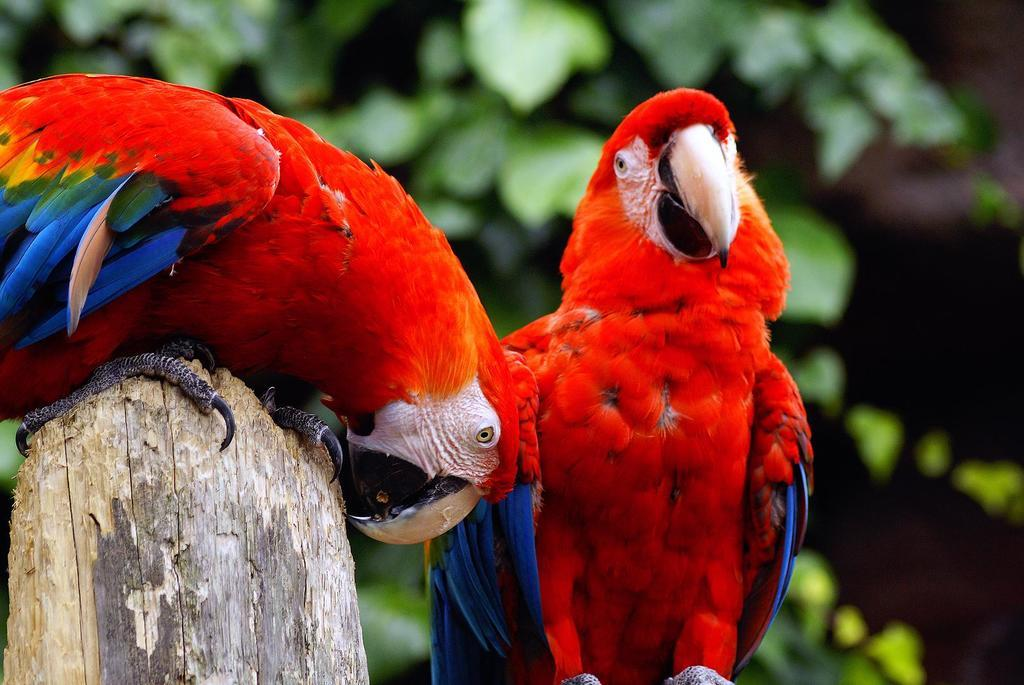What is the main subject of the image? The main subject of the image is a bird on a wooden object. Are there any other birds in the image? Yes, there is another bird in the image. Can you describe the background of the image? The background of the image is blurry. What type of pies can be seen in the image? There are no pies present in the image. Where is the hall located in the image? There is no hall present in the image. 